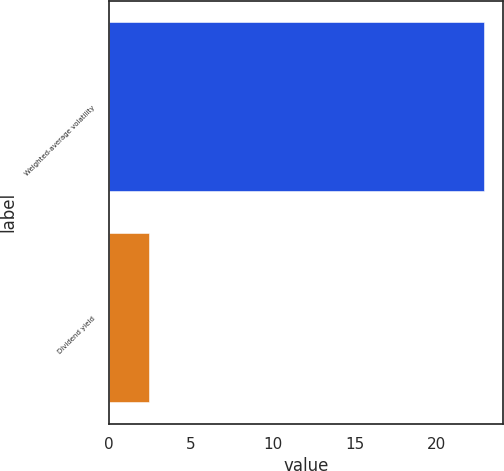Convert chart to OTSL. <chart><loc_0><loc_0><loc_500><loc_500><bar_chart><fcel>Weighted-average volatility<fcel>Dividend yield<nl><fcel>22.9<fcel>2.46<nl></chart> 